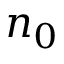<formula> <loc_0><loc_0><loc_500><loc_500>n _ { 0 }</formula> 